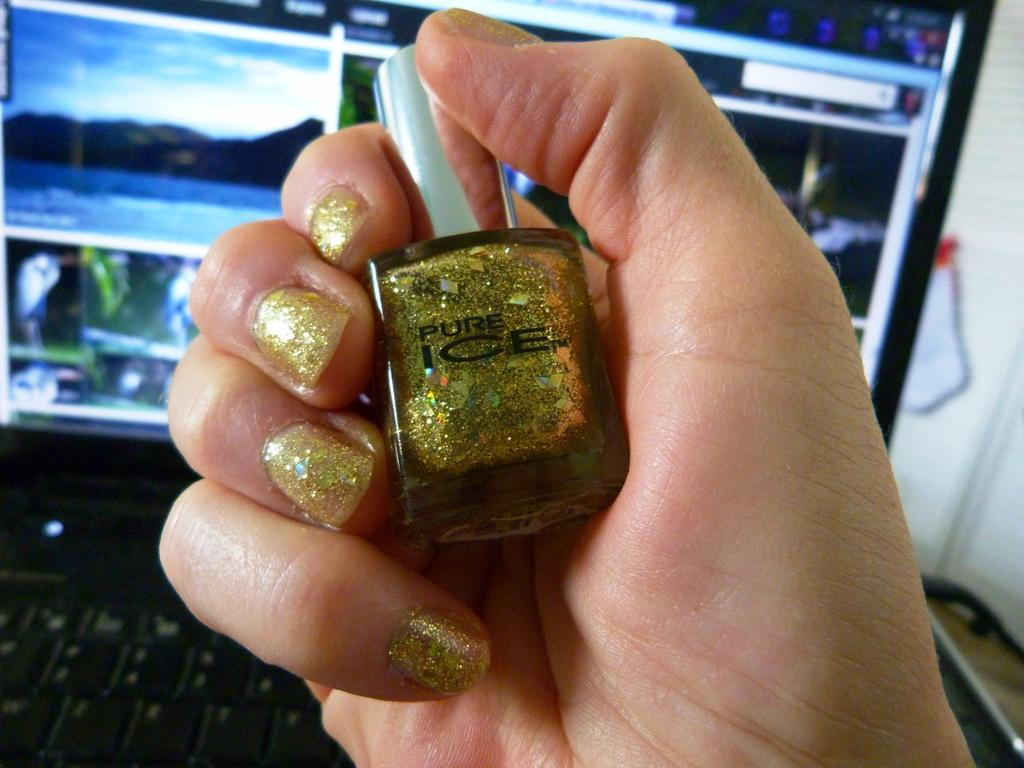<image>
Give a short and clear explanation of the subsequent image. Hand with gold painted nails holding Pure Ice nail polish bottle 